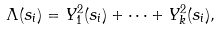Convert formula to latex. <formula><loc_0><loc_0><loc_500><loc_500>\Lambda ( s _ { i } ) = Y _ { 1 } ^ { 2 } ( s _ { i } ) + \cdots + Y _ { k } ^ { 2 } ( s _ { i } ) ,</formula> 